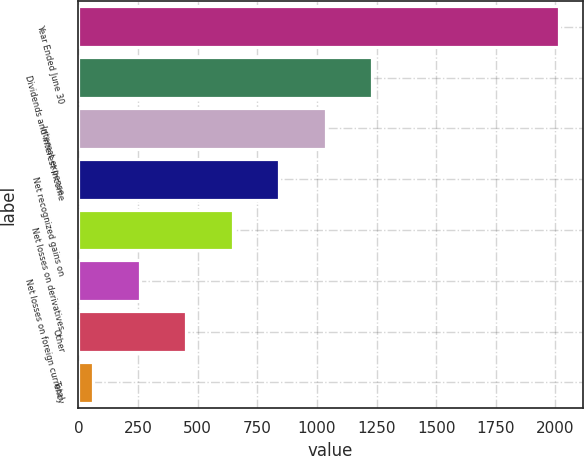Convert chart. <chart><loc_0><loc_0><loc_500><loc_500><bar_chart><fcel>Year Ended June 30<fcel>Dividends and interest income<fcel>Interest expense<fcel>Net recognized gains on<fcel>Net losses on derivatives<fcel>Net losses on foreign currency<fcel>Other<fcel>Total<nl><fcel>2014<fcel>1232.8<fcel>1037.5<fcel>842.2<fcel>646.9<fcel>256.3<fcel>451.6<fcel>61<nl></chart> 